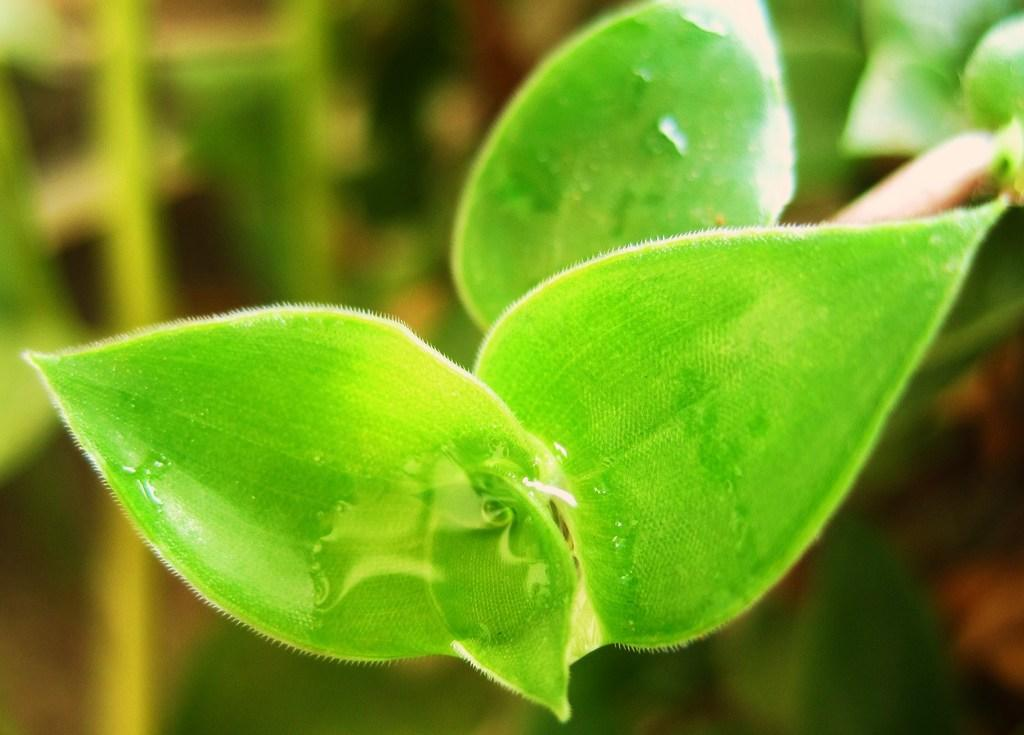What type of living organism can be seen in the image? There is a plant in the image. What type of bedroom furniture is visible in the image? There is no bedroom furniture present in the image, as it only contains a plant. What type of bait is used to catch fish in the image? There is no fishing or bait present in the image, as it only contains a plant. 